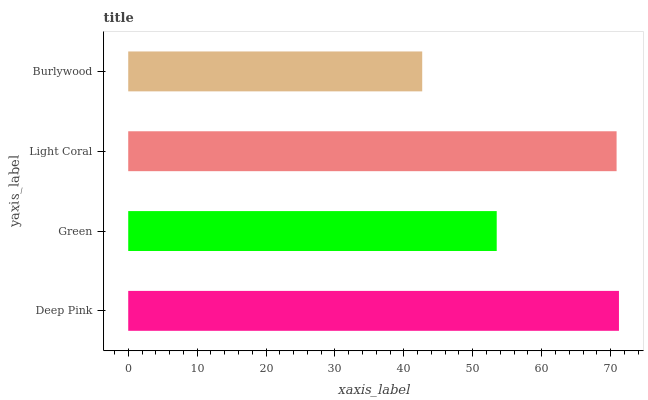Is Burlywood the minimum?
Answer yes or no. Yes. Is Deep Pink the maximum?
Answer yes or no. Yes. Is Green the minimum?
Answer yes or no. No. Is Green the maximum?
Answer yes or no. No. Is Deep Pink greater than Green?
Answer yes or no. Yes. Is Green less than Deep Pink?
Answer yes or no. Yes. Is Green greater than Deep Pink?
Answer yes or no. No. Is Deep Pink less than Green?
Answer yes or no. No. Is Light Coral the high median?
Answer yes or no. Yes. Is Green the low median?
Answer yes or no. Yes. Is Deep Pink the high median?
Answer yes or no. No. Is Burlywood the low median?
Answer yes or no. No. 